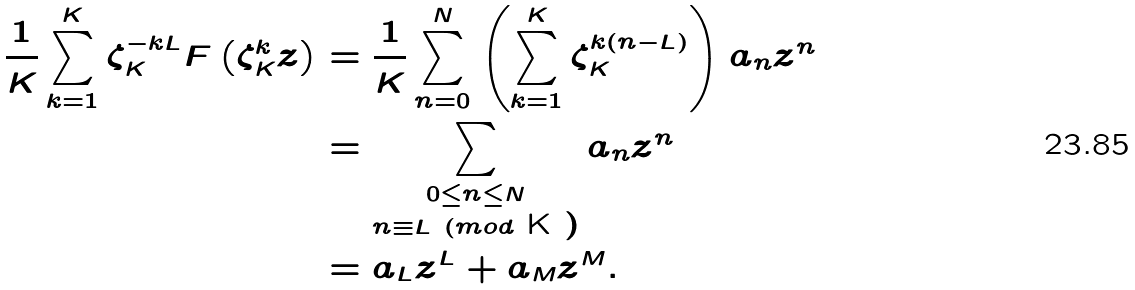Convert formula to latex. <formula><loc_0><loc_0><loc_500><loc_500>\frac { 1 } { K } \sum _ { k = 1 } ^ { K } \zeta _ { K } ^ { - k L } F \left ( \zeta _ { K } ^ { k } z \right ) & = \frac { 1 } { K } \sum _ { n = 0 } ^ { N } \left ( \sum _ { k = 1 } ^ { K } \zeta _ { K } ^ { k ( n - L ) } \right ) a _ { n } z ^ { n } \\ & = \sum _ { \substack { 0 \leq n \leq N \\ n \equiv L \ ( m o d $ K $ ) } } a _ { n } z ^ { n } \\ & = a _ { L } z ^ { L } + a _ { M } z ^ { M } .</formula> 